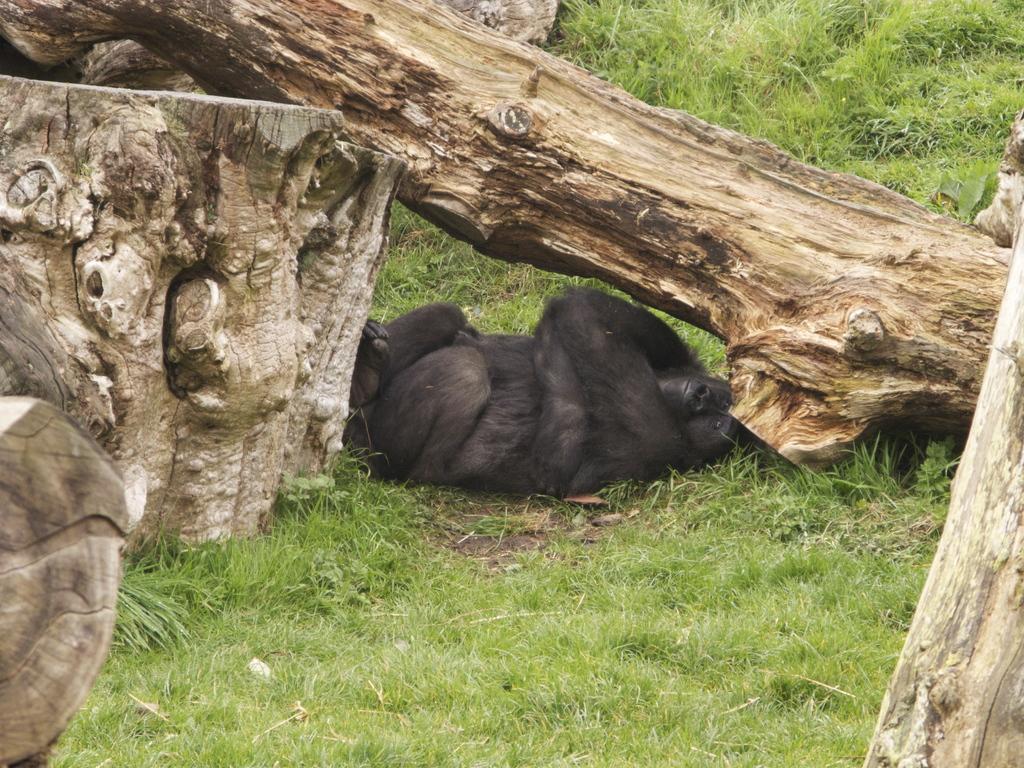Please provide a concise description of this image. In this image I can see an animal which is in black color. It is lying under the wooden log. To the side I can see few more wooden logs and the grass. 